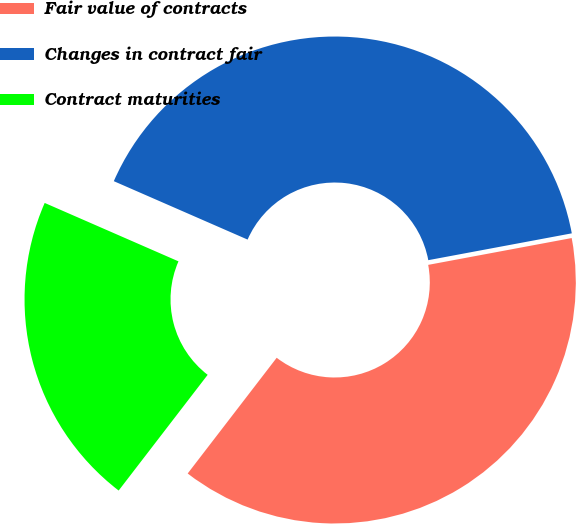<chart> <loc_0><loc_0><loc_500><loc_500><pie_chart><fcel>Fair value of contracts<fcel>Changes in contract fair<fcel>Contract maturities<nl><fcel>38.38%<fcel>40.51%<fcel>21.12%<nl></chart> 